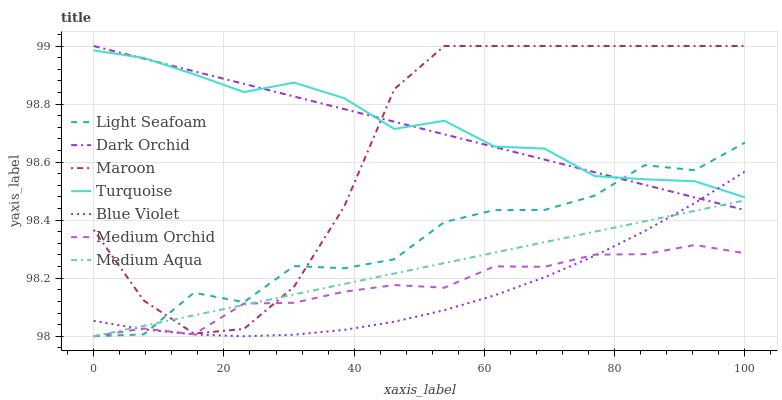Does Blue Violet have the minimum area under the curve?
Answer yes or no. Yes. Does Turquoise have the maximum area under the curve?
Answer yes or no. Yes. Does Medium Orchid have the minimum area under the curve?
Answer yes or no. No. Does Medium Orchid have the maximum area under the curve?
Answer yes or no. No. Is Dark Orchid the smoothest?
Answer yes or no. Yes. Is Light Seafoam the roughest?
Answer yes or no. Yes. Is Medium Orchid the smoothest?
Answer yes or no. No. Is Medium Orchid the roughest?
Answer yes or no. No. Does Medium Orchid have the lowest value?
Answer yes or no. Yes. Does Maroon have the lowest value?
Answer yes or no. No. Does Dark Orchid have the highest value?
Answer yes or no. Yes. Does Medium Orchid have the highest value?
Answer yes or no. No. Is Medium Orchid less than Turquoise?
Answer yes or no. Yes. Is Turquoise greater than Medium Orchid?
Answer yes or no. Yes. Does Light Seafoam intersect Blue Violet?
Answer yes or no. Yes. Is Light Seafoam less than Blue Violet?
Answer yes or no. No. Is Light Seafoam greater than Blue Violet?
Answer yes or no. No. Does Medium Orchid intersect Turquoise?
Answer yes or no. No. 